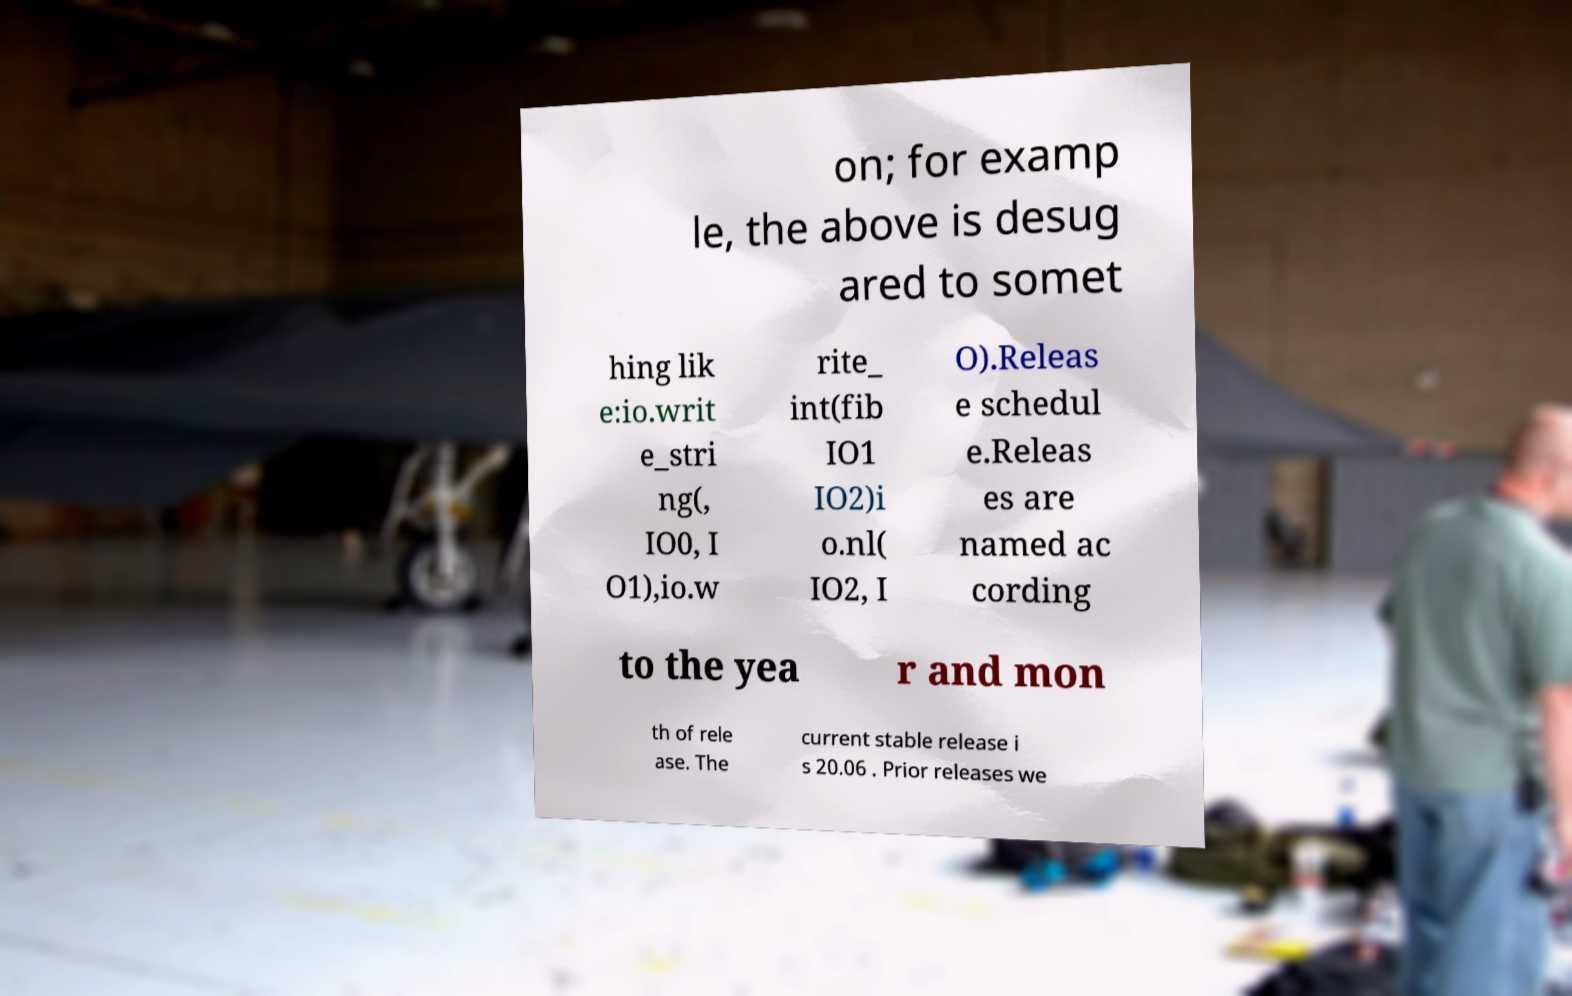For documentation purposes, I need the text within this image transcribed. Could you provide that? on; for examp le, the above is desug ared to somet hing lik e:io.writ e_stri ng(, IO0, I O1),io.w rite_ int(fib IO1 IO2)i o.nl( IO2, I O).Releas e schedul e.Releas es are named ac cording to the yea r and mon th of rele ase. The current stable release i s 20.06 . Prior releases we 